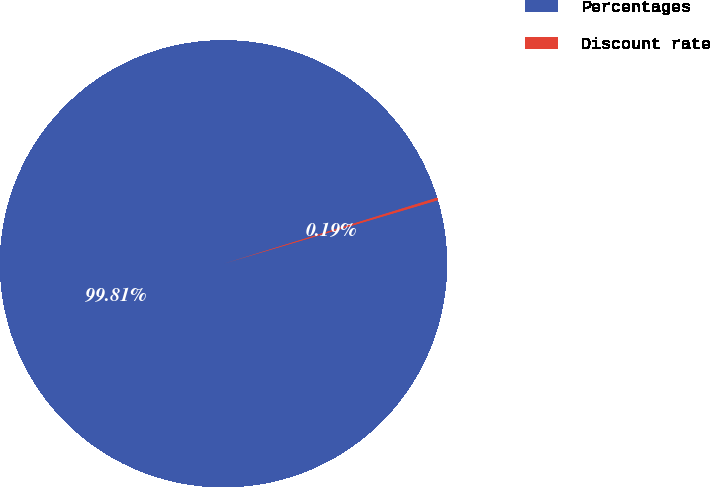Convert chart. <chart><loc_0><loc_0><loc_500><loc_500><pie_chart><fcel>Percentages<fcel>Discount rate<nl><fcel>99.81%<fcel>0.19%<nl></chart> 